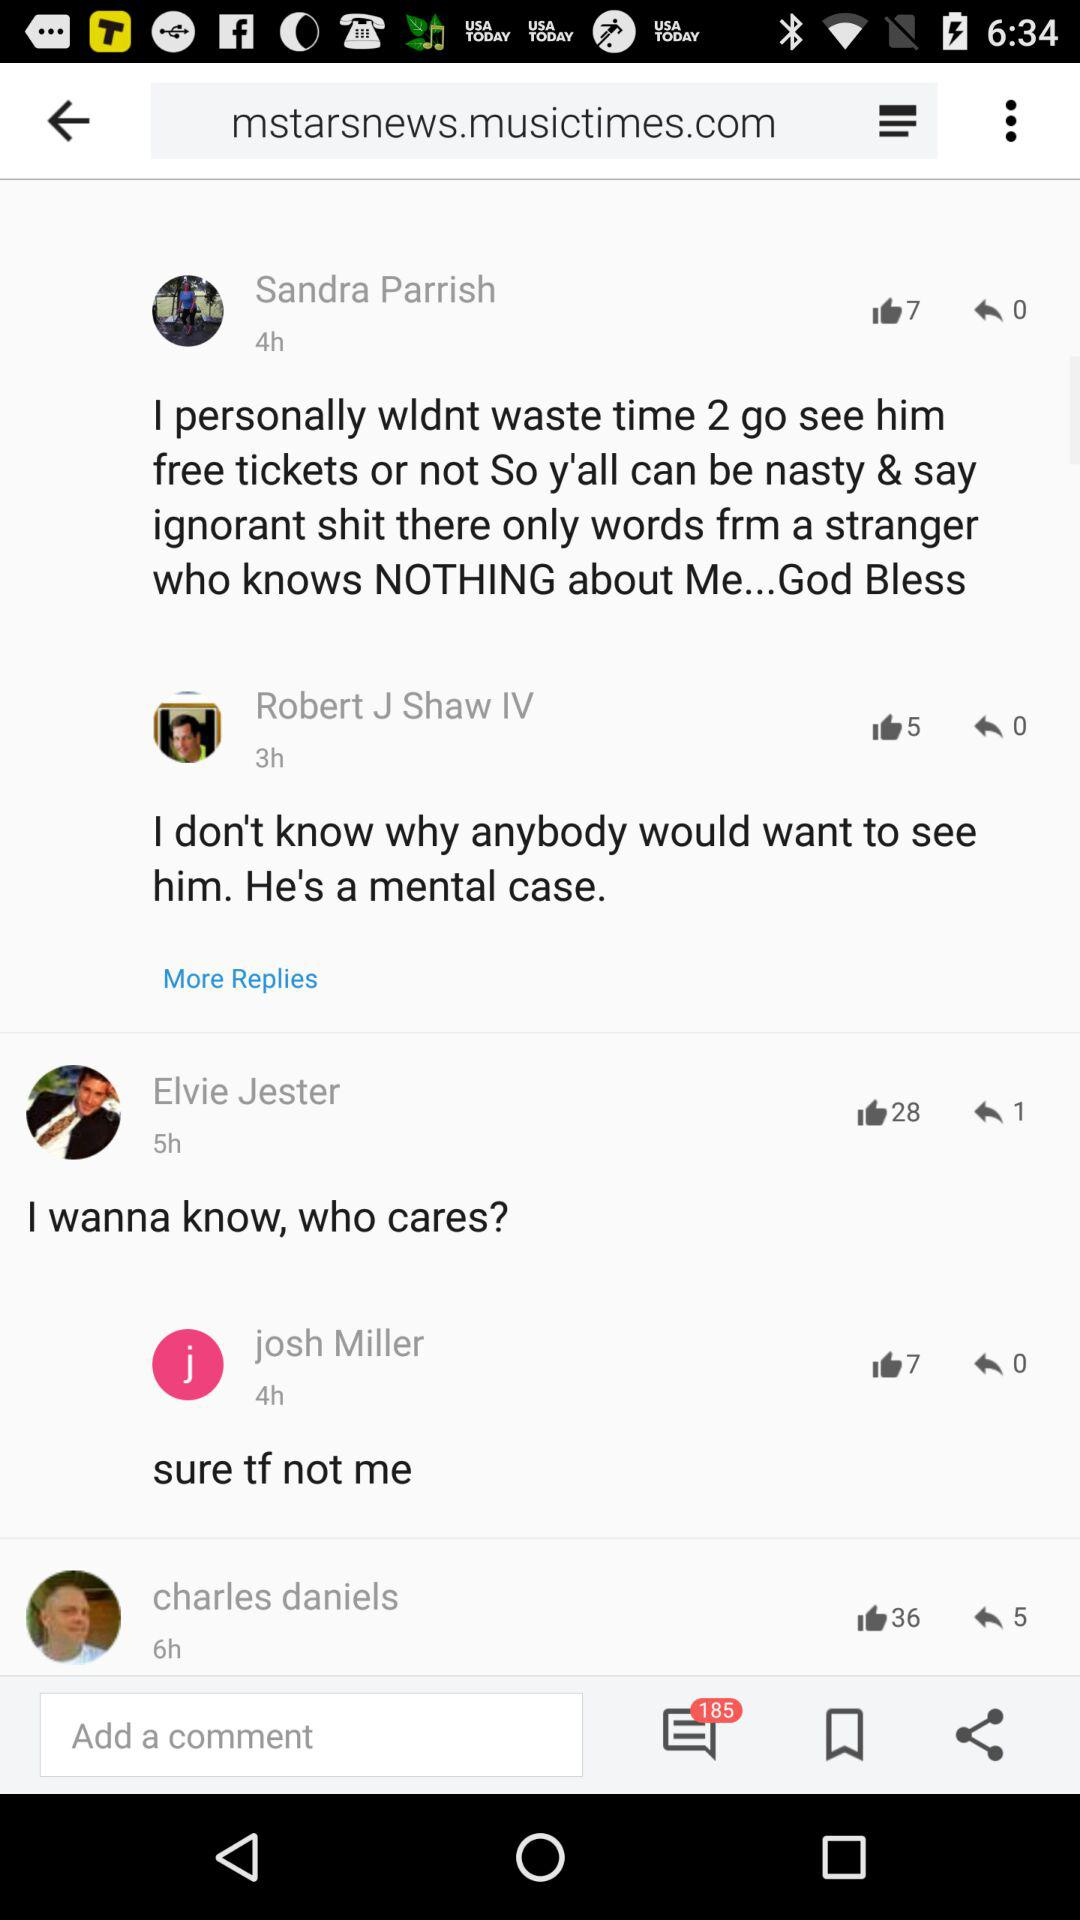How many unread messages are there? There are 185 unread messages. 